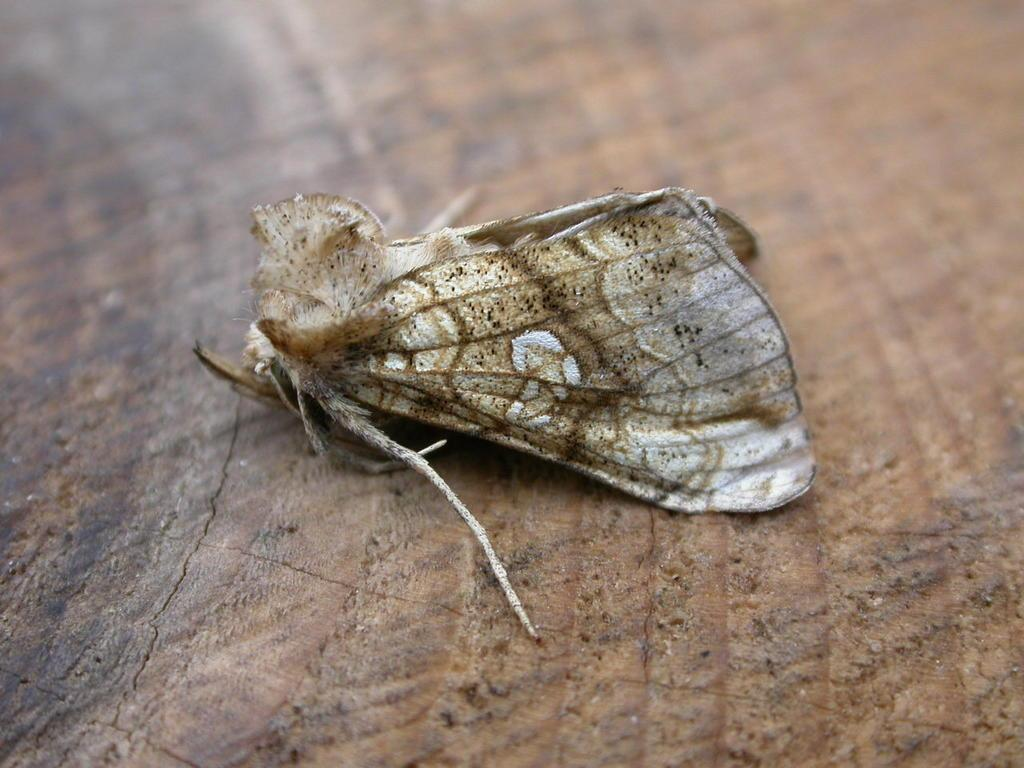What type of insect is present in the image? There is a moth in the image. Can you describe the moth's location in the image? The moth is on an object. What type of card is the moth holding in the image? There is no card present in the image, and the moth is not holding anything. 